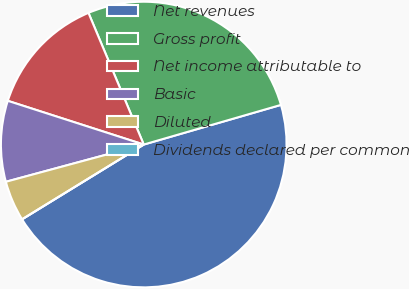<chart> <loc_0><loc_0><loc_500><loc_500><pie_chart><fcel>Net revenues<fcel>Gross profit<fcel>Net income attributable to<fcel>Basic<fcel>Diluted<fcel>Dividends declared per common<nl><fcel>45.71%<fcel>26.85%<fcel>13.72%<fcel>9.15%<fcel>4.57%<fcel>0.0%<nl></chart> 